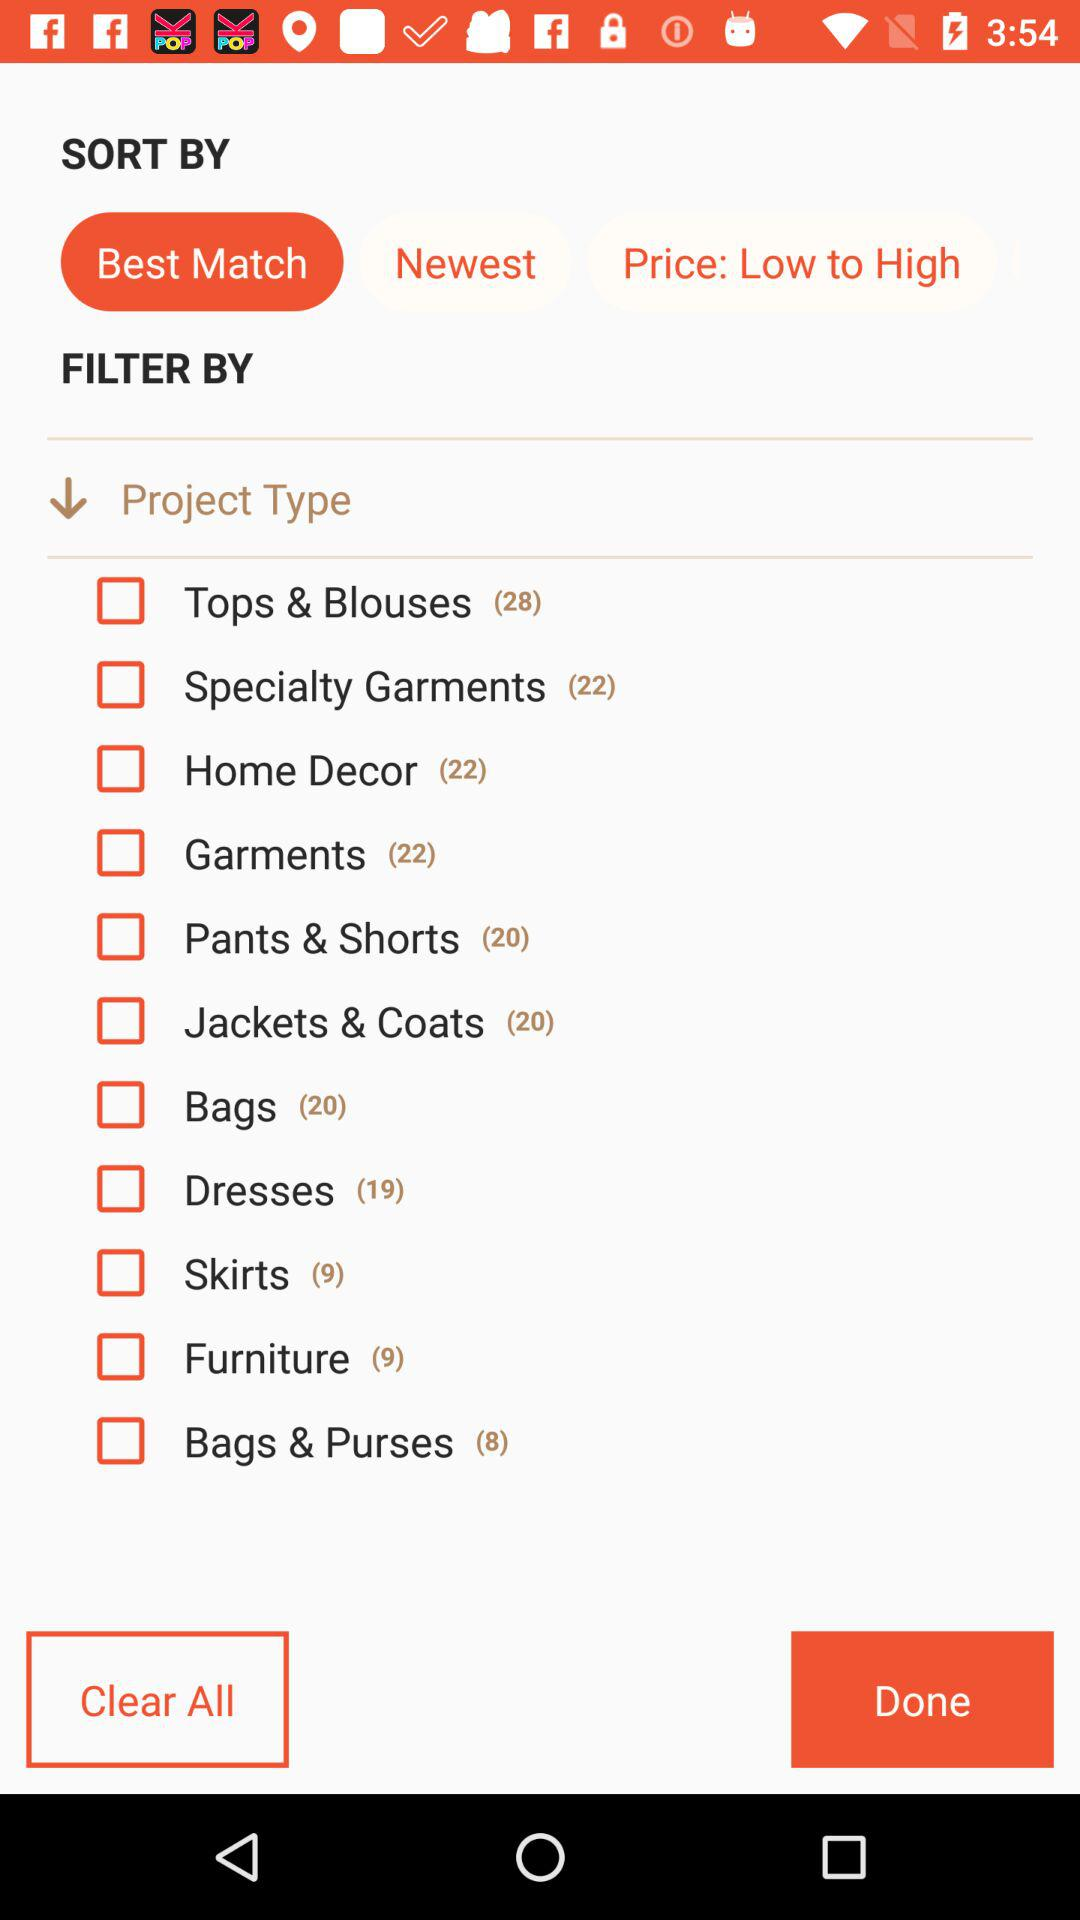How many skirts are there? There are 9 skirts. 